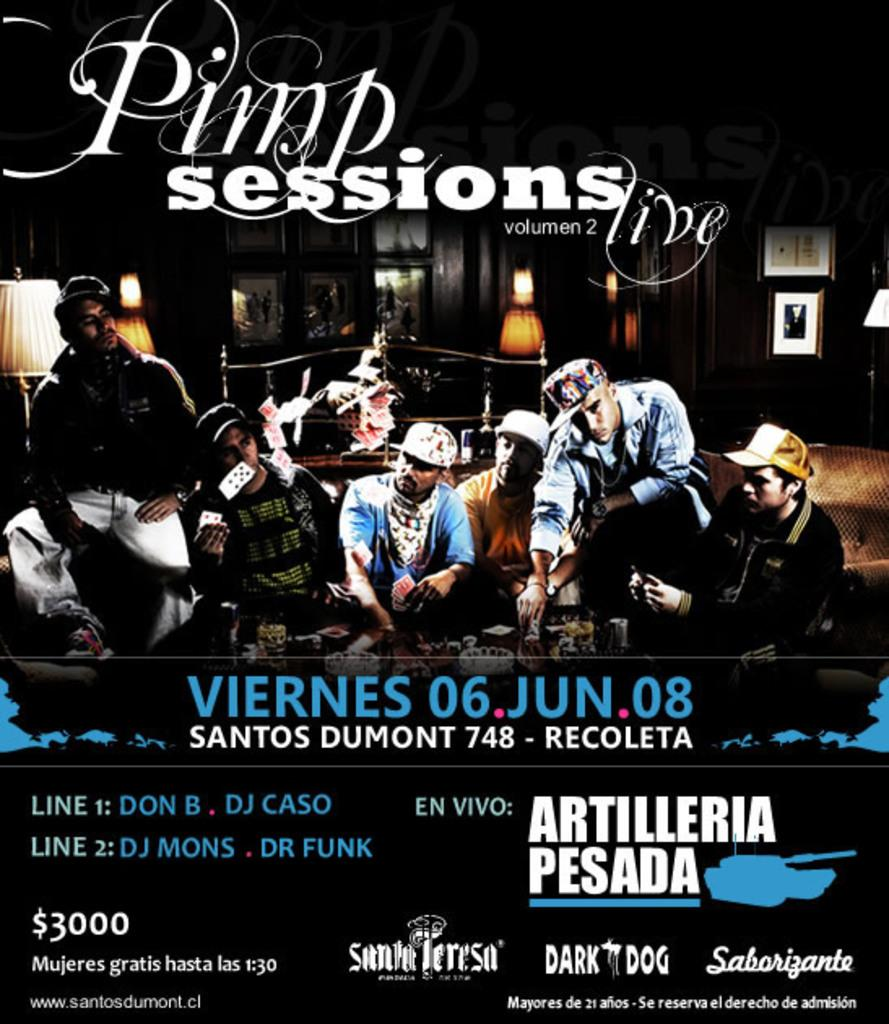<image>
Provide a brief description of the given image. A music presentation is advertised as the Pimp Sessions Volume 2. 